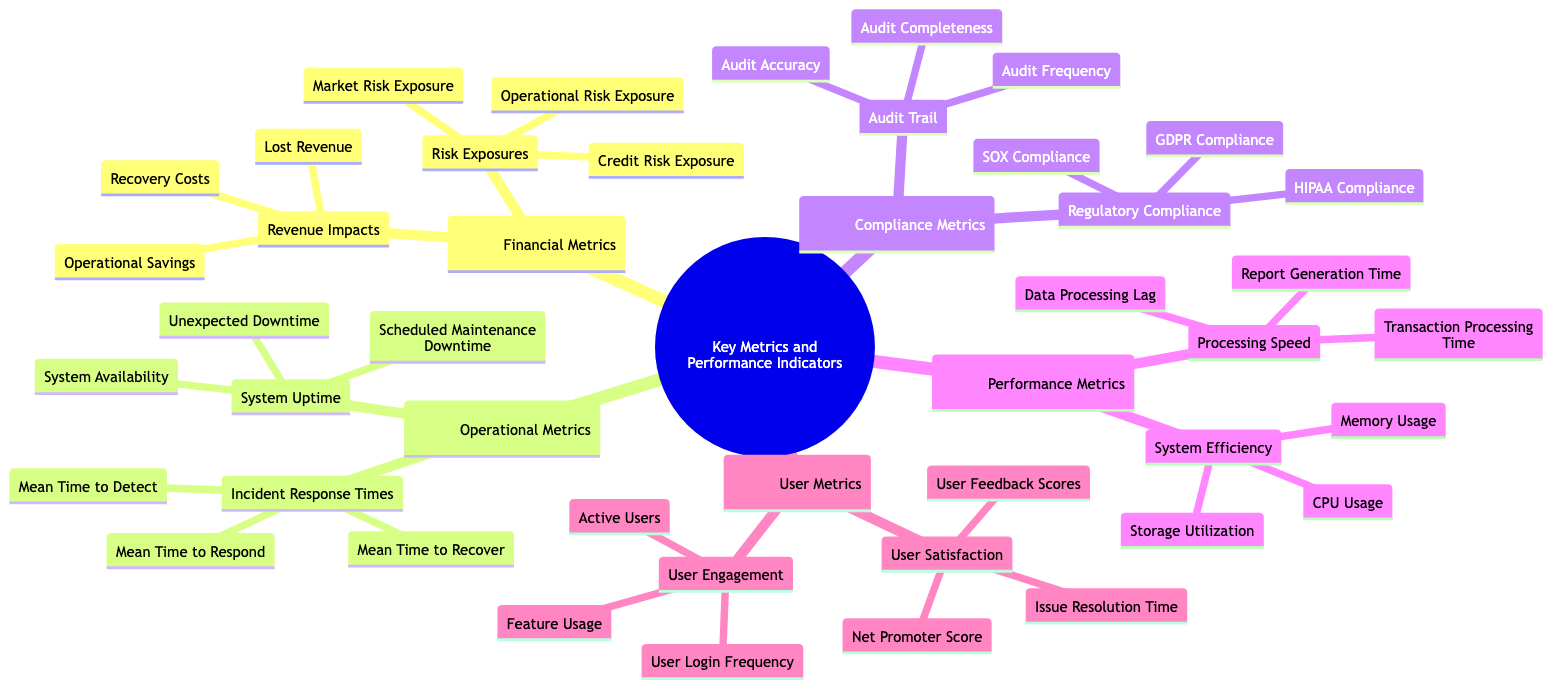What are the three categories of metrics in the diagram? The diagram has five main categories: Financial Metrics, Operational Metrics, Compliance Metrics, Performance Metrics, and User Metrics.
Answer: Financial Metrics, Operational Metrics, Compliance Metrics, Performance Metrics, User Metrics How many metrics are listed under Financial Metrics? Under Financial Metrics, there are two main areas: Revenue Impacts (with three items) and Risk Exposures (with three items), totaling six metrics.
Answer: Six What is one of the measures under Performance Metrics? The Performance Metrics section includes two areas: Processing Speed and System Efficiency. An example from Processing Speed is Transaction Processing Time.
Answer: Transaction Processing Time How does User Satisfaction relate to User Engagement? User Satisfaction and User Engagement are both components under User Metrics, but they measure different aspects: one assesses the quality of user experience, while the other looks at how actively users utilize the system.
Answer: They are both components of User Metrics Which sub-metric corresponds to Regulatory Compliance? Under Compliance Metrics, Regulatory Compliance includes GDPR Compliance, SOX Compliance, and HIPAA Compliance. Any of these could be a valid answer. For example, GDPR Compliance corresponds to Regulatory Compliance.
Answer: GDPR Compliance What is the total number of sub-metrics under Operational Metrics? Operational Metrics contains two areas: Incident Response Times (with three metrics) and System Uptime (with three metrics), leading to a total of six sub-metrics.
Answer: Six Which metric indicates the speed at which transactions are processed? The metric that indicates the speed at which transactions are processed is Transaction Processing Time, which falls under Processing Speed in Performance Metrics.
Answer: Transaction Processing Time What is the meaning of Audit Completeness? Audit Completeness is a sub-metric under Audit Trail in Compliance Metrics, focusing on the thoroughness of the audits conducted.
Answer: Thoroughness of audits conducted 